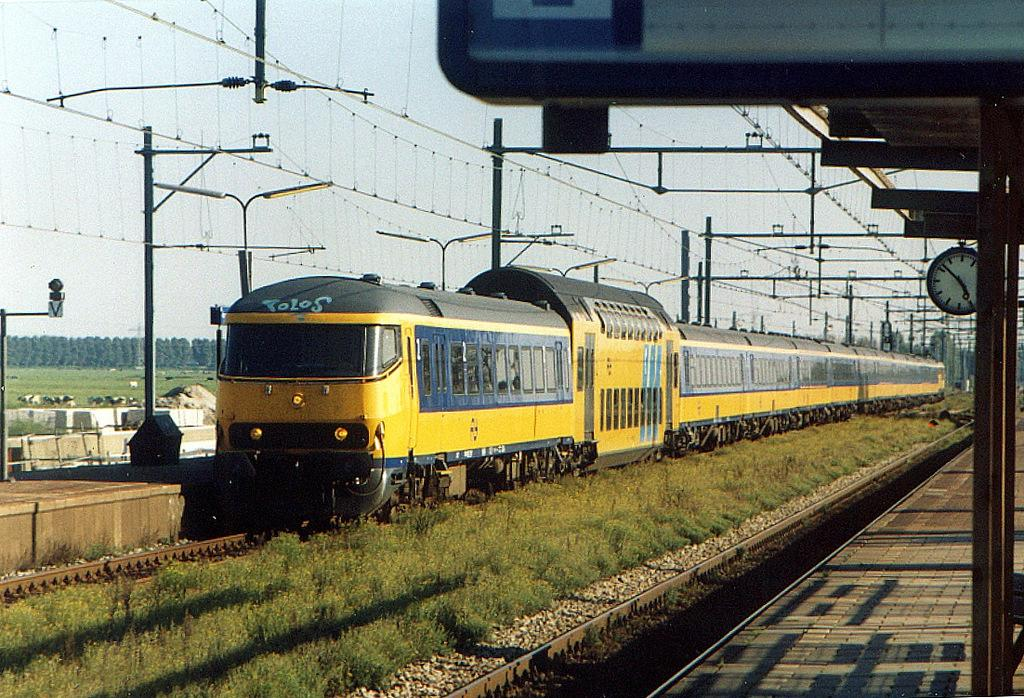<image>
Describe the image concisely. a yellow and blue train on the tracks with the word polos on the top of the train. 